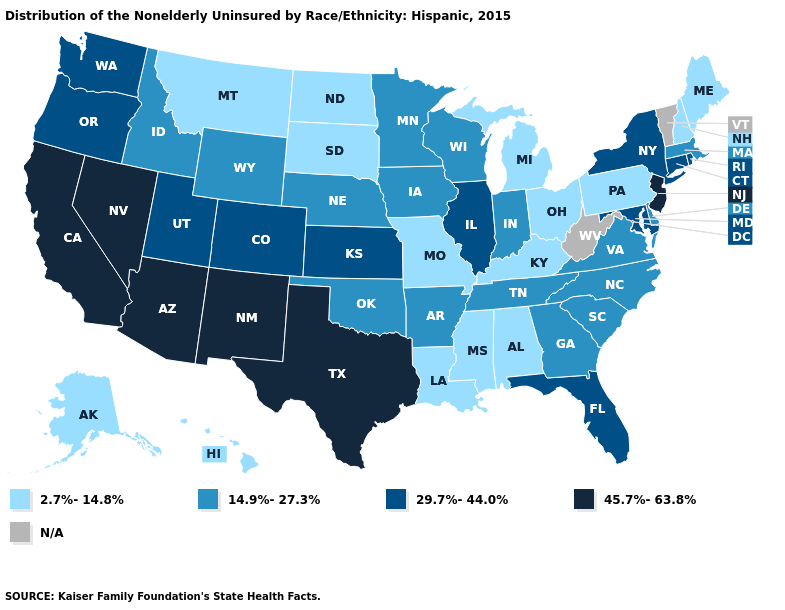Does Texas have the lowest value in the USA?
Answer briefly. No. Does the first symbol in the legend represent the smallest category?
Write a very short answer. Yes. Among the states that border Kansas , which have the highest value?
Keep it brief. Colorado. Name the states that have a value in the range 45.7%-63.8%?
Quick response, please. Arizona, California, Nevada, New Jersey, New Mexico, Texas. Which states have the lowest value in the Northeast?
Keep it brief. Maine, New Hampshire, Pennsylvania. What is the value of Pennsylvania?
Quick response, please. 2.7%-14.8%. Name the states that have a value in the range 29.7%-44.0%?
Answer briefly. Colorado, Connecticut, Florida, Illinois, Kansas, Maryland, New York, Oregon, Rhode Island, Utah, Washington. Among the states that border Colorado , does New Mexico have the highest value?
Give a very brief answer. Yes. Among the states that border Maryland , does Virginia have the highest value?
Quick response, please. Yes. Name the states that have a value in the range 14.9%-27.3%?
Write a very short answer. Arkansas, Delaware, Georgia, Idaho, Indiana, Iowa, Massachusetts, Minnesota, Nebraska, North Carolina, Oklahoma, South Carolina, Tennessee, Virginia, Wisconsin, Wyoming. Name the states that have a value in the range 29.7%-44.0%?
Keep it brief. Colorado, Connecticut, Florida, Illinois, Kansas, Maryland, New York, Oregon, Rhode Island, Utah, Washington. What is the value of New Mexico?
Keep it brief. 45.7%-63.8%. Name the states that have a value in the range 45.7%-63.8%?
Concise answer only. Arizona, California, Nevada, New Jersey, New Mexico, Texas. What is the value of Delaware?
Short answer required. 14.9%-27.3%. What is the value of Indiana?
Quick response, please. 14.9%-27.3%. 